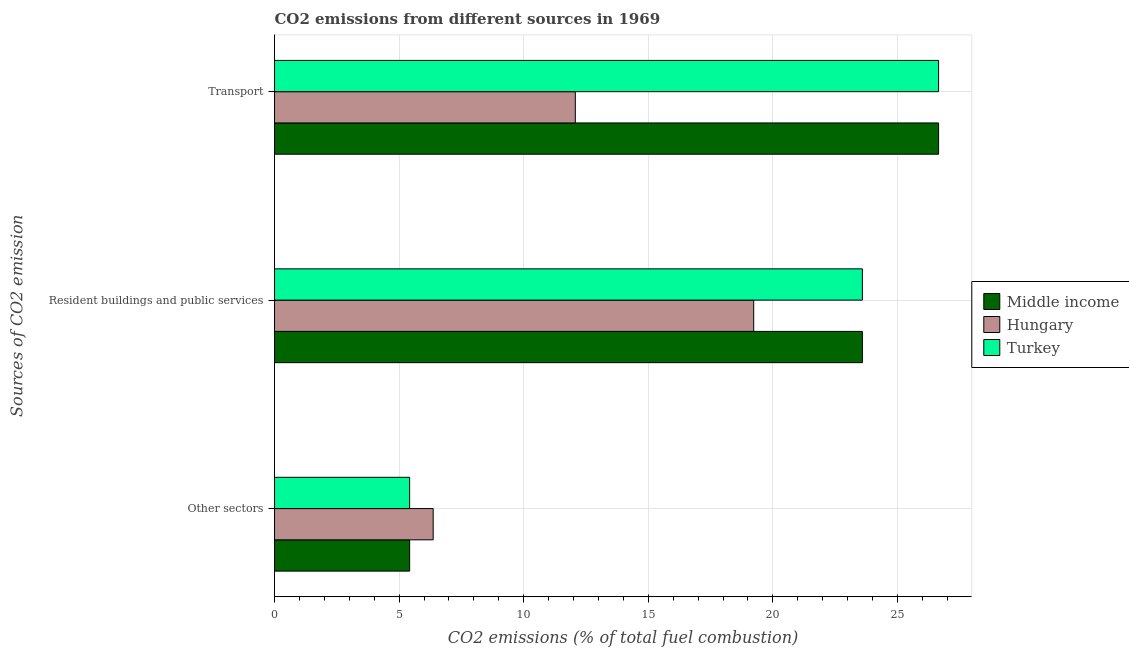How many groups of bars are there?
Offer a very short reply. 3. Are the number of bars per tick equal to the number of legend labels?
Keep it short and to the point. Yes. How many bars are there on the 3rd tick from the top?
Ensure brevity in your answer.  3. How many bars are there on the 3rd tick from the bottom?
Ensure brevity in your answer.  3. What is the label of the 1st group of bars from the top?
Your answer should be very brief. Transport. What is the percentage of co2 emissions from transport in Hungary?
Provide a succinct answer. 12.07. Across all countries, what is the maximum percentage of co2 emissions from resident buildings and public services?
Give a very brief answer. 23.59. Across all countries, what is the minimum percentage of co2 emissions from resident buildings and public services?
Provide a short and direct response. 19.23. In which country was the percentage of co2 emissions from resident buildings and public services minimum?
Ensure brevity in your answer.  Hungary. What is the total percentage of co2 emissions from resident buildings and public services in the graph?
Your answer should be very brief. 66.42. What is the difference between the percentage of co2 emissions from other sectors in Hungary and that in Middle income?
Your response must be concise. 0.94. What is the difference between the percentage of co2 emissions from resident buildings and public services in Turkey and the percentage of co2 emissions from other sectors in Hungary?
Your response must be concise. 17.23. What is the average percentage of co2 emissions from other sectors per country?
Make the answer very short. 5.74. What is the difference between the percentage of co2 emissions from other sectors and percentage of co2 emissions from transport in Turkey?
Ensure brevity in your answer.  -21.23. In how many countries, is the percentage of co2 emissions from resident buildings and public services greater than 11 %?
Give a very brief answer. 3. What is the ratio of the percentage of co2 emissions from transport in Hungary to that in Middle income?
Give a very brief answer. 0.45. Is the percentage of co2 emissions from other sectors in Turkey less than that in Middle income?
Your answer should be very brief. No. Is the difference between the percentage of co2 emissions from other sectors in Hungary and Middle income greater than the difference between the percentage of co2 emissions from resident buildings and public services in Hungary and Middle income?
Offer a terse response. Yes. What is the difference between the highest and the second highest percentage of co2 emissions from other sectors?
Your response must be concise. 0.94. What is the difference between the highest and the lowest percentage of co2 emissions from transport?
Make the answer very short. 14.58. What does the 2nd bar from the top in Resident buildings and public services represents?
Offer a terse response. Hungary. What does the 1st bar from the bottom in Transport represents?
Provide a short and direct response. Middle income. Are all the bars in the graph horizontal?
Offer a very short reply. Yes. Does the graph contain any zero values?
Your answer should be compact. No. How are the legend labels stacked?
Make the answer very short. Vertical. What is the title of the graph?
Make the answer very short. CO2 emissions from different sources in 1969. What is the label or title of the X-axis?
Offer a terse response. CO2 emissions (% of total fuel combustion). What is the label or title of the Y-axis?
Make the answer very short. Sources of CO2 emission. What is the CO2 emissions (% of total fuel combustion) in Middle income in Other sectors?
Offer a terse response. 5.42. What is the CO2 emissions (% of total fuel combustion) of Hungary in Other sectors?
Offer a very short reply. 6.37. What is the CO2 emissions (% of total fuel combustion) of Turkey in Other sectors?
Offer a terse response. 5.42. What is the CO2 emissions (% of total fuel combustion) in Middle income in Resident buildings and public services?
Offer a very short reply. 23.59. What is the CO2 emissions (% of total fuel combustion) of Hungary in Resident buildings and public services?
Provide a succinct answer. 19.23. What is the CO2 emissions (% of total fuel combustion) in Turkey in Resident buildings and public services?
Provide a short and direct response. 23.59. What is the CO2 emissions (% of total fuel combustion) of Middle income in Transport?
Ensure brevity in your answer.  26.65. What is the CO2 emissions (% of total fuel combustion) in Hungary in Transport?
Give a very brief answer. 12.07. What is the CO2 emissions (% of total fuel combustion) of Turkey in Transport?
Your response must be concise. 26.65. Across all Sources of CO2 emission, what is the maximum CO2 emissions (% of total fuel combustion) of Middle income?
Give a very brief answer. 26.65. Across all Sources of CO2 emission, what is the maximum CO2 emissions (% of total fuel combustion) of Hungary?
Give a very brief answer. 19.23. Across all Sources of CO2 emission, what is the maximum CO2 emissions (% of total fuel combustion) of Turkey?
Your answer should be very brief. 26.65. Across all Sources of CO2 emission, what is the minimum CO2 emissions (% of total fuel combustion) of Middle income?
Your answer should be very brief. 5.42. Across all Sources of CO2 emission, what is the minimum CO2 emissions (% of total fuel combustion) in Hungary?
Give a very brief answer. 6.37. Across all Sources of CO2 emission, what is the minimum CO2 emissions (% of total fuel combustion) of Turkey?
Offer a very short reply. 5.42. What is the total CO2 emissions (% of total fuel combustion) of Middle income in the graph?
Offer a terse response. 55.67. What is the total CO2 emissions (% of total fuel combustion) in Hungary in the graph?
Offer a very short reply. 37.67. What is the total CO2 emissions (% of total fuel combustion) in Turkey in the graph?
Offer a very short reply. 55.67. What is the difference between the CO2 emissions (% of total fuel combustion) of Middle income in Other sectors and that in Resident buildings and public services?
Your response must be concise. -18.17. What is the difference between the CO2 emissions (% of total fuel combustion) of Hungary in Other sectors and that in Resident buildings and public services?
Your response must be concise. -12.86. What is the difference between the CO2 emissions (% of total fuel combustion) in Turkey in Other sectors and that in Resident buildings and public services?
Your answer should be very brief. -18.17. What is the difference between the CO2 emissions (% of total fuel combustion) of Middle income in Other sectors and that in Transport?
Keep it short and to the point. -21.23. What is the difference between the CO2 emissions (% of total fuel combustion) in Hungary in Other sectors and that in Transport?
Give a very brief answer. -5.7. What is the difference between the CO2 emissions (% of total fuel combustion) in Turkey in Other sectors and that in Transport?
Provide a succinct answer. -21.23. What is the difference between the CO2 emissions (% of total fuel combustion) in Middle income in Resident buildings and public services and that in Transport?
Your answer should be very brief. -3.06. What is the difference between the CO2 emissions (% of total fuel combustion) in Hungary in Resident buildings and public services and that in Transport?
Keep it short and to the point. 7.16. What is the difference between the CO2 emissions (% of total fuel combustion) in Turkey in Resident buildings and public services and that in Transport?
Keep it short and to the point. -3.06. What is the difference between the CO2 emissions (% of total fuel combustion) of Middle income in Other sectors and the CO2 emissions (% of total fuel combustion) of Hungary in Resident buildings and public services?
Ensure brevity in your answer.  -13.81. What is the difference between the CO2 emissions (% of total fuel combustion) of Middle income in Other sectors and the CO2 emissions (% of total fuel combustion) of Turkey in Resident buildings and public services?
Your response must be concise. -18.17. What is the difference between the CO2 emissions (% of total fuel combustion) in Hungary in Other sectors and the CO2 emissions (% of total fuel combustion) in Turkey in Resident buildings and public services?
Provide a short and direct response. -17.23. What is the difference between the CO2 emissions (% of total fuel combustion) of Middle income in Other sectors and the CO2 emissions (% of total fuel combustion) of Hungary in Transport?
Offer a terse response. -6.65. What is the difference between the CO2 emissions (% of total fuel combustion) of Middle income in Other sectors and the CO2 emissions (% of total fuel combustion) of Turkey in Transport?
Offer a terse response. -21.23. What is the difference between the CO2 emissions (% of total fuel combustion) in Hungary in Other sectors and the CO2 emissions (% of total fuel combustion) in Turkey in Transport?
Provide a short and direct response. -20.28. What is the difference between the CO2 emissions (% of total fuel combustion) in Middle income in Resident buildings and public services and the CO2 emissions (% of total fuel combustion) in Hungary in Transport?
Your response must be concise. 11.52. What is the difference between the CO2 emissions (% of total fuel combustion) in Middle income in Resident buildings and public services and the CO2 emissions (% of total fuel combustion) in Turkey in Transport?
Your answer should be compact. -3.06. What is the difference between the CO2 emissions (% of total fuel combustion) in Hungary in Resident buildings and public services and the CO2 emissions (% of total fuel combustion) in Turkey in Transport?
Make the answer very short. -7.42. What is the average CO2 emissions (% of total fuel combustion) in Middle income per Sources of CO2 emission?
Make the answer very short. 18.56. What is the average CO2 emissions (% of total fuel combustion) of Hungary per Sources of CO2 emission?
Provide a succinct answer. 12.56. What is the average CO2 emissions (% of total fuel combustion) of Turkey per Sources of CO2 emission?
Provide a short and direct response. 18.56. What is the difference between the CO2 emissions (% of total fuel combustion) of Middle income and CO2 emissions (% of total fuel combustion) of Hungary in Other sectors?
Your answer should be very brief. -0.94. What is the difference between the CO2 emissions (% of total fuel combustion) in Hungary and CO2 emissions (% of total fuel combustion) in Turkey in Other sectors?
Ensure brevity in your answer.  0.94. What is the difference between the CO2 emissions (% of total fuel combustion) in Middle income and CO2 emissions (% of total fuel combustion) in Hungary in Resident buildings and public services?
Give a very brief answer. 4.36. What is the difference between the CO2 emissions (% of total fuel combustion) of Hungary and CO2 emissions (% of total fuel combustion) of Turkey in Resident buildings and public services?
Offer a very short reply. -4.36. What is the difference between the CO2 emissions (% of total fuel combustion) of Middle income and CO2 emissions (% of total fuel combustion) of Hungary in Transport?
Keep it short and to the point. 14.58. What is the difference between the CO2 emissions (% of total fuel combustion) in Middle income and CO2 emissions (% of total fuel combustion) in Turkey in Transport?
Your response must be concise. 0. What is the difference between the CO2 emissions (% of total fuel combustion) in Hungary and CO2 emissions (% of total fuel combustion) in Turkey in Transport?
Provide a succinct answer. -14.58. What is the ratio of the CO2 emissions (% of total fuel combustion) of Middle income in Other sectors to that in Resident buildings and public services?
Provide a short and direct response. 0.23. What is the ratio of the CO2 emissions (% of total fuel combustion) of Hungary in Other sectors to that in Resident buildings and public services?
Your response must be concise. 0.33. What is the ratio of the CO2 emissions (% of total fuel combustion) in Turkey in Other sectors to that in Resident buildings and public services?
Make the answer very short. 0.23. What is the ratio of the CO2 emissions (% of total fuel combustion) in Middle income in Other sectors to that in Transport?
Make the answer very short. 0.2. What is the ratio of the CO2 emissions (% of total fuel combustion) in Hungary in Other sectors to that in Transport?
Provide a short and direct response. 0.53. What is the ratio of the CO2 emissions (% of total fuel combustion) of Turkey in Other sectors to that in Transport?
Provide a succinct answer. 0.2. What is the ratio of the CO2 emissions (% of total fuel combustion) in Middle income in Resident buildings and public services to that in Transport?
Offer a very short reply. 0.89. What is the ratio of the CO2 emissions (% of total fuel combustion) in Hungary in Resident buildings and public services to that in Transport?
Keep it short and to the point. 1.59. What is the ratio of the CO2 emissions (% of total fuel combustion) of Turkey in Resident buildings and public services to that in Transport?
Ensure brevity in your answer.  0.89. What is the difference between the highest and the second highest CO2 emissions (% of total fuel combustion) in Middle income?
Provide a succinct answer. 3.06. What is the difference between the highest and the second highest CO2 emissions (% of total fuel combustion) in Hungary?
Offer a terse response. 7.16. What is the difference between the highest and the second highest CO2 emissions (% of total fuel combustion) of Turkey?
Keep it short and to the point. 3.06. What is the difference between the highest and the lowest CO2 emissions (% of total fuel combustion) of Middle income?
Keep it short and to the point. 21.23. What is the difference between the highest and the lowest CO2 emissions (% of total fuel combustion) in Hungary?
Your answer should be very brief. 12.86. What is the difference between the highest and the lowest CO2 emissions (% of total fuel combustion) in Turkey?
Provide a succinct answer. 21.23. 